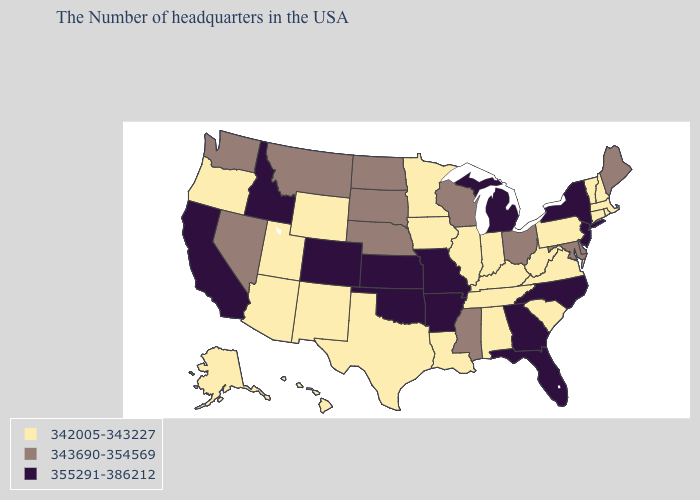Name the states that have a value in the range 343690-354569?
Quick response, please. Maine, Delaware, Maryland, Ohio, Wisconsin, Mississippi, Nebraska, South Dakota, North Dakota, Montana, Nevada, Washington. What is the highest value in states that border Nebraska?
Be succinct. 355291-386212. What is the value of Arkansas?
Answer briefly. 355291-386212. What is the value of Minnesota?
Concise answer only. 342005-343227. Does the first symbol in the legend represent the smallest category?
Write a very short answer. Yes. Which states have the lowest value in the South?
Give a very brief answer. Virginia, South Carolina, West Virginia, Kentucky, Alabama, Tennessee, Louisiana, Texas. Does South Carolina have a lower value than Michigan?
Quick response, please. Yes. What is the highest value in states that border Ohio?
Be succinct. 355291-386212. What is the highest value in the MidWest ?
Give a very brief answer. 355291-386212. What is the value of Colorado?
Concise answer only. 355291-386212. Which states have the highest value in the USA?
Write a very short answer. New York, New Jersey, North Carolina, Florida, Georgia, Michigan, Missouri, Arkansas, Kansas, Oklahoma, Colorado, Idaho, California. What is the value of Michigan?
Quick response, please. 355291-386212. Among the states that border Texas , does New Mexico have the lowest value?
Answer briefly. Yes. How many symbols are there in the legend?
Write a very short answer. 3. 